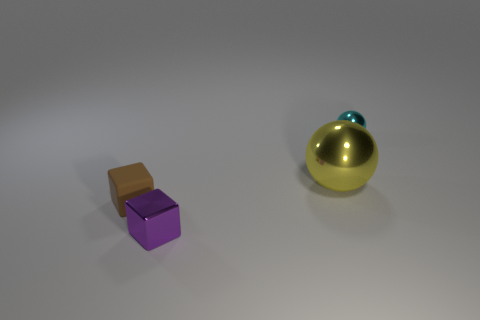There is a small object left of the small object that is in front of the matte block; what shape is it?
Your response must be concise. Cube. Are there any other things that are the same size as the yellow thing?
Your answer should be compact. No. How many things are either large cyan rubber spheres or small cubes?
Ensure brevity in your answer.  2. Is there a metallic object of the same size as the matte object?
Provide a short and direct response. Yes. What is the shape of the purple thing?
Offer a very short reply. Cube. Is the number of small objects right of the big yellow metallic sphere greater than the number of tiny cyan balls to the left of the brown cube?
Your answer should be compact. Yes. The brown matte object that is the same size as the purple thing is what shape?
Your response must be concise. Cube. Is there a small cyan metal thing that has the same shape as the big yellow thing?
Your answer should be very brief. Yes. Is the material of the ball on the left side of the small cyan metallic sphere the same as the tiny thing that is on the right side of the tiny purple block?
Provide a succinct answer. Yes. What number of small spheres have the same material as the yellow object?
Keep it short and to the point. 1. 